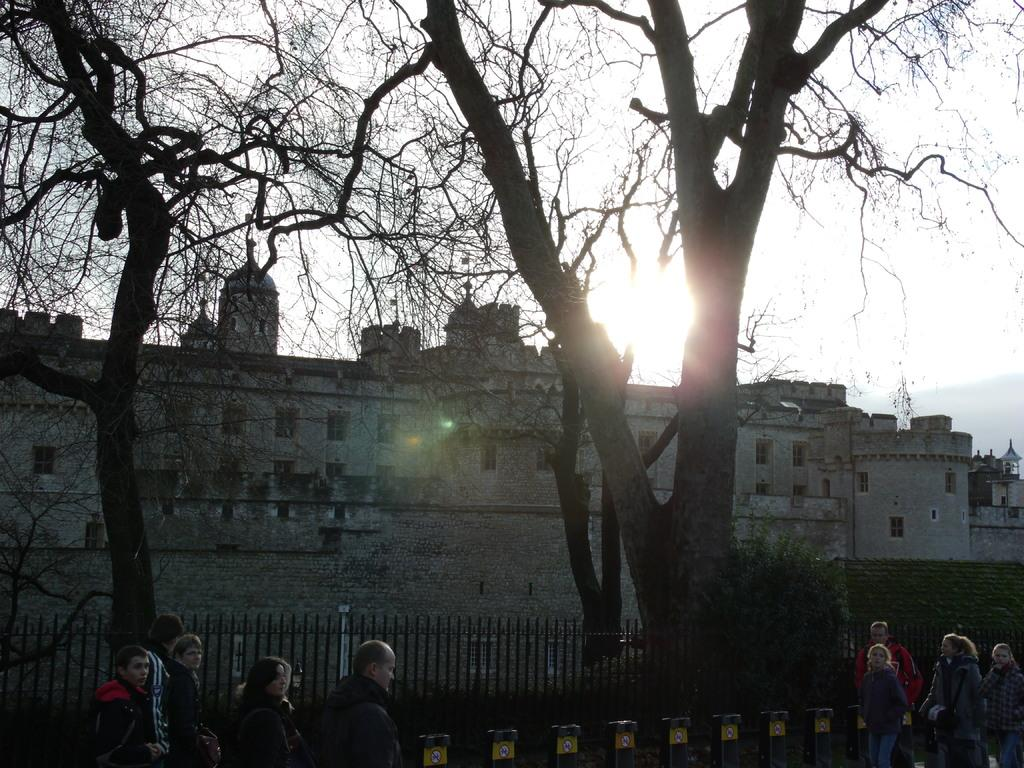How many people are present in the image? There are many people in the image. What can be seen near the people? There are small poles near the people. What type of natural elements are present in the image? There are trees in the image. What architectural features can be seen in the image? There are railings in the image. What is visible in the background of the image? There is sky and buildings with windows visible in the background of the image. What story is being told by the advertisement on the side of the building in the image? There is no advertisement present on the side of the building in the image. What activity are the people participating in, as depicted in the image? The image does not show the people participating in any specific activity; they are simply standing or walking. 